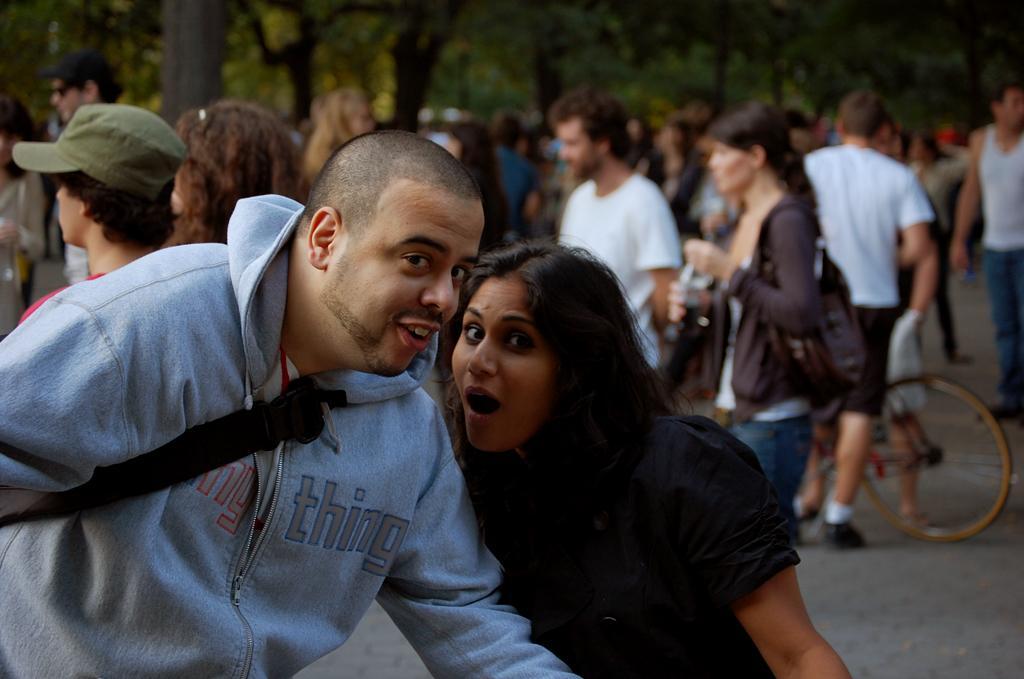Can you describe this image briefly? In this image we can see group of persons standing on the ground. One woman is wearing a black dress. To the right side of the image we can see a bicycle on the ground. In the background, we can see a group of trees. 